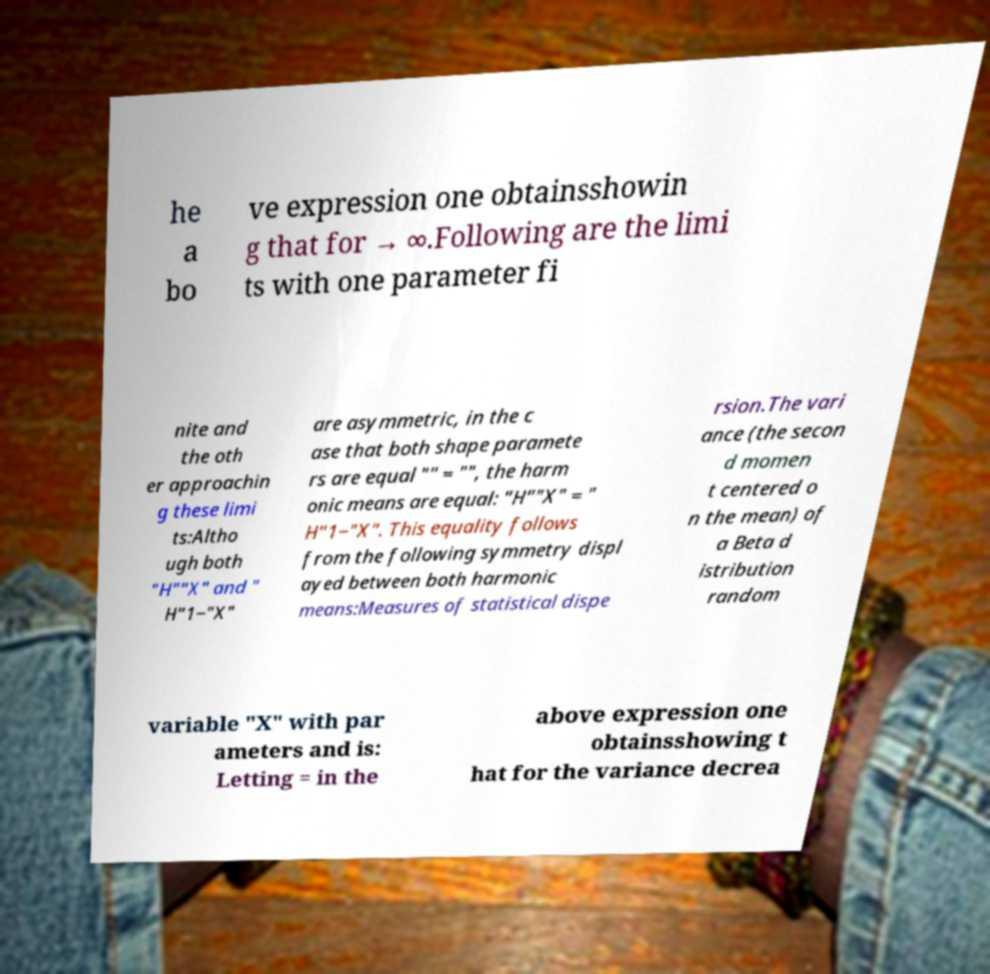Please read and relay the text visible in this image. What does it say? he a bo ve expression one obtainsshowin g that for → ∞.Following are the limi ts with one parameter fi nite and the oth er approachin g these limi ts:Altho ugh both "H""X" and " H"1−"X" are asymmetric, in the c ase that both shape paramete rs are equal "" = "", the harm onic means are equal: "H""X" = " H"1−"X". This equality follows from the following symmetry displ ayed between both harmonic means:Measures of statistical dispe rsion.The vari ance (the secon d momen t centered o n the mean) of a Beta d istribution random variable "X" with par ameters and is: Letting = in the above expression one obtainsshowing t hat for the variance decrea 